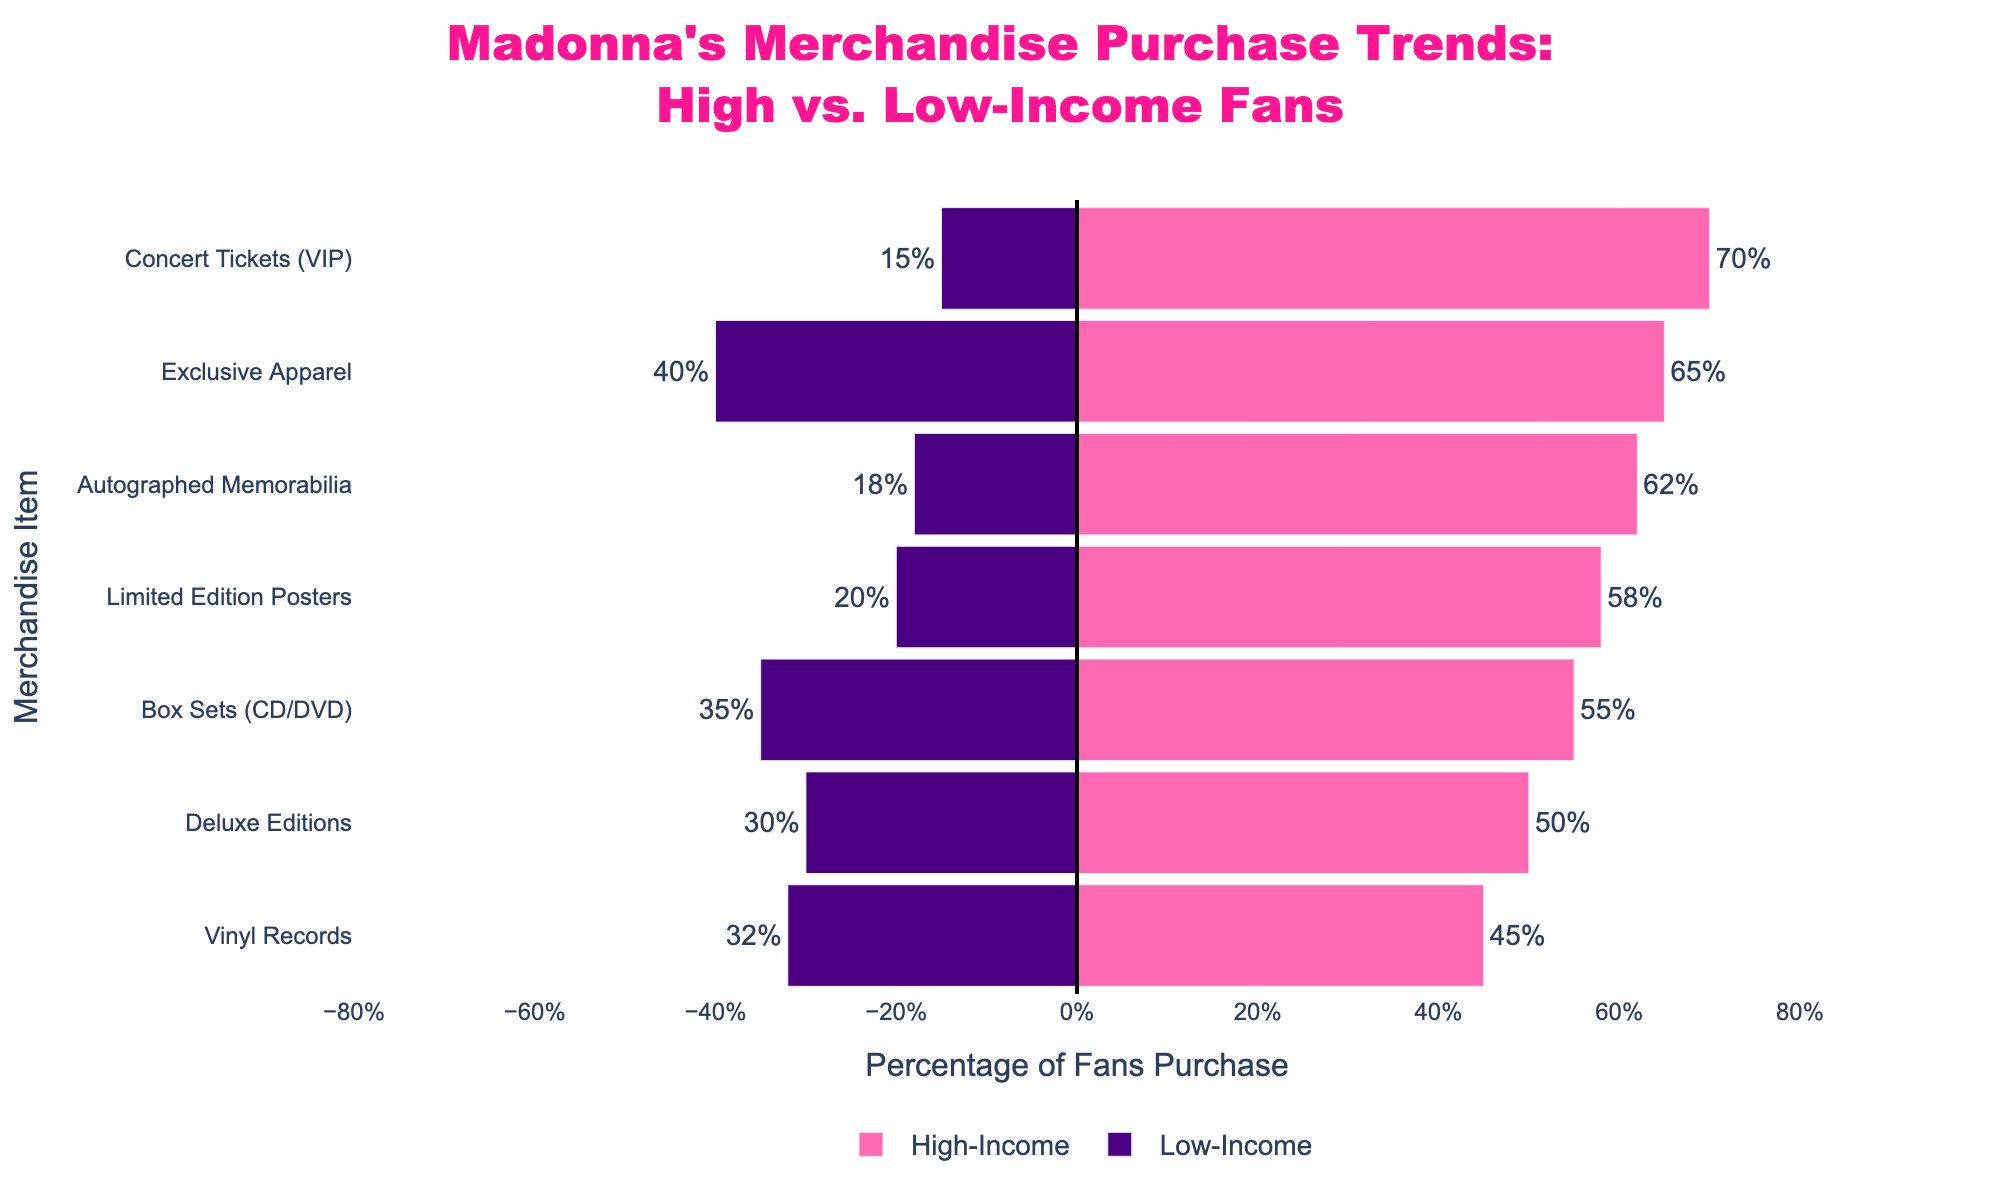What merchandise item has the highest percentage of purchase among high-income fans? The highest bar in the high-income fans section is associated with “Concert Tickets (VIP)” at 70%.
Answer: Concert Tickets (VIP) What is the difference in purchase percentage for exclusive apparel between high-income and low-income fans? High-income fans have a purchase percentage of 65% for exclusive apparel, while low-income fans have 40%. The difference is 65% - 40% = 25%.
Answer: 25% Which income group purchases more autographed memorabilia, and by what percentage? High-income fans purchase autographed memorabilia at 62%, whereas low-income fans purchase it at 18%. The difference is 62% - 18% = 44%, with high-income fans purchasing more.
Answer: High-Income, 44% Which merchandise item has the smallest gap in purchase percentage between high-income and low-income fans? For Deluxe Editions, the difference between high-income fans (50%) and low-income fans (30%) is 20%, which is the smallest gap compared to other items.
Answer: Deluxe Editions How much higher is the purchase percentage of limited edition posters for high-income fans compared to low-income fans? The purchase percentage for high-income fans is 58% for limited edition posters, while it's 20% for low-income fans. So, it's 58% - 20% = 38% higher for high-income fans.
Answer: 38% What is the total percentage difference for concert tickets (VIP) between the two income groups? The difference in purchase percentage for concert tickets (VIP) between high-income fans (70%) and low-income fans (15%) is 70% - 15% = 55%.
Answer: 55% Which group shows a lower interest in box sets (CD/DVD), and what is the percentage? Low-income fans show lower interest in box sets with a purchase percentage of 35% compared to high-income fans.
Answer: Low-Income, 35% Is there any merchandise category where low-income fans' purchase percentage is higher than high-income fans? No, in all the categories, high-income fans have a higher purchase percentage compared to low-income fans.
Answer: No What's the average purchase percentage of vinyl records for both income groups combined? High-income fans purchase at 45%, and low-income fans at 32%. The average is (45% + 32%) / 2 = 38.5%.
Answer: 38.5% 